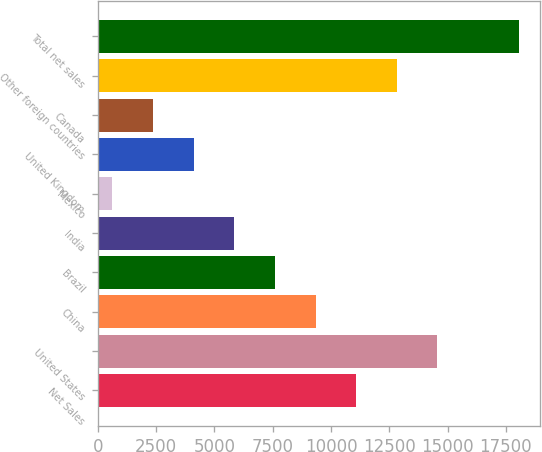<chart> <loc_0><loc_0><loc_500><loc_500><bar_chart><fcel>Net Sales<fcel>United States<fcel>China<fcel>Brazil<fcel>India<fcel>Mexico<fcel>United Kingdom<fcel>Canada<fcel>Other foreign countries<fcel>Total net sales<nl><fcel>11081.2<fcel>14564.6<fcel>9339.5<fcel>7597.8<fcel>5856.1<fcel>631<fcel>4114.4<fcel>2372.7<fcel>12822.9<fcel>18048<nl></chart> 